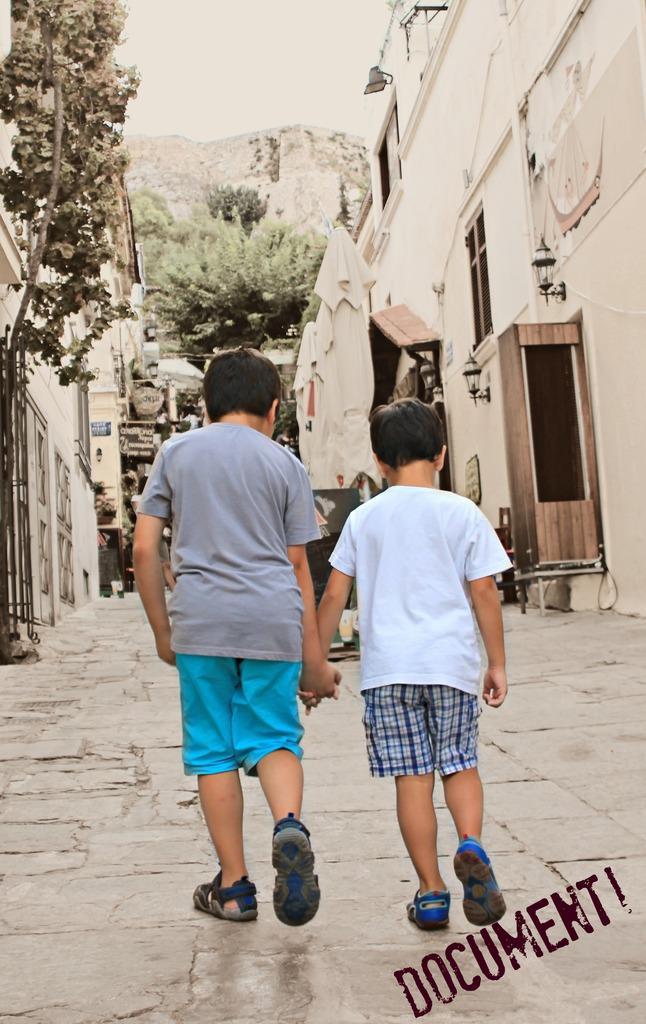In one or two sentences, can you explain what this image depicts? In this image, we can see two kids are walking on the walkway. Background we can see so many houses, walls, trees, lights and mountain. Top of the image, there is a sky. 